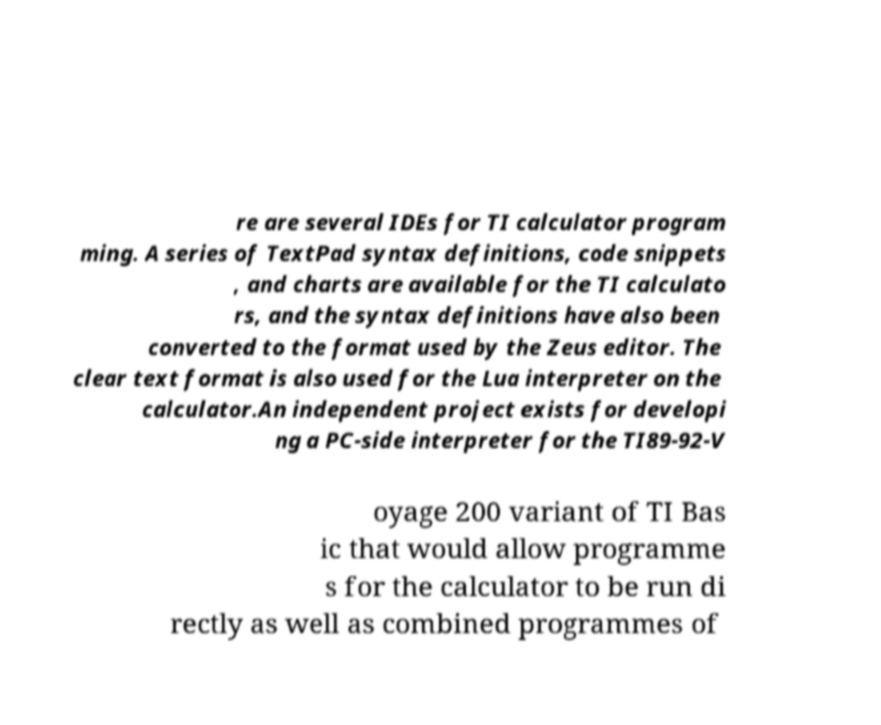There's text embedded in this image that I need extracted. Can you transcribe it verbatim? re are several IDEs for TI calculator program ming. A series of TextPad syntax definitions, code snippets , and charts are available for the TI calculato rs, and the syntax definitions have also been converted to the format used by the Zeus editor. The clear text format is also used for the Lua interpreter on the calculator.An independent project exists for developi ng a PC-side interpreter for the TI89-92-V oyage 200 variant of TI Bas ic that would allow programme s for the calculator to be run di rectly as well as combined programmes of 